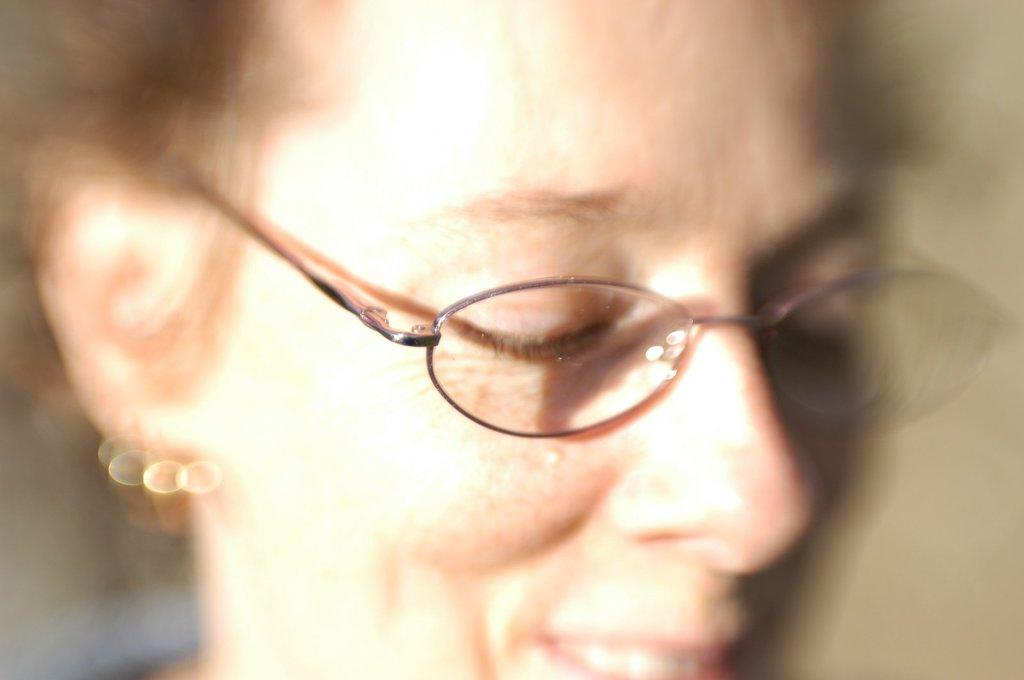What is the main subject of the image? There is a person in the image. Can you describe any specific feature of the person? The person's face is wearing spectacles. How many tins are stacked on the person's head in the image? There are no tins present in the image; the person is wearing spectacles on their face. 